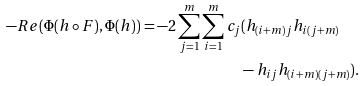Convert formula to latex. <formula><loc_0><loc_0><loc_500><loc_500>- R e ( \Phi ( h \circ F ) , \Phi ( h ) ) = - 2 \sum _ { j = 1 } ^ { m } \sum _ { i = 1 } ^ { m } c _ { j } & ( h _ { ( i + m ) j } h _ { i ( j + m ) } \\ & - h _ { i j } h _ { ( i + m ) ( j + m ) } ) .</formula> 